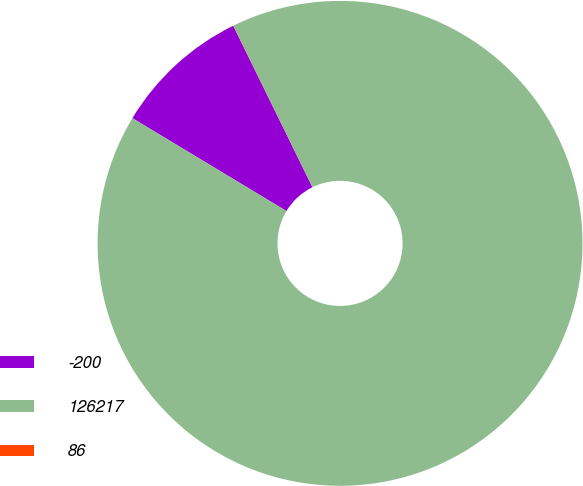Convert chart. <chart><loc_0><loc_0><loc_500><loc_500><pie_chart><fcel>-200<fcel>126217<fcel>86<nl><fcel>9.1%<fcel>90.9%<fcel>0.01%<nl></chart> 